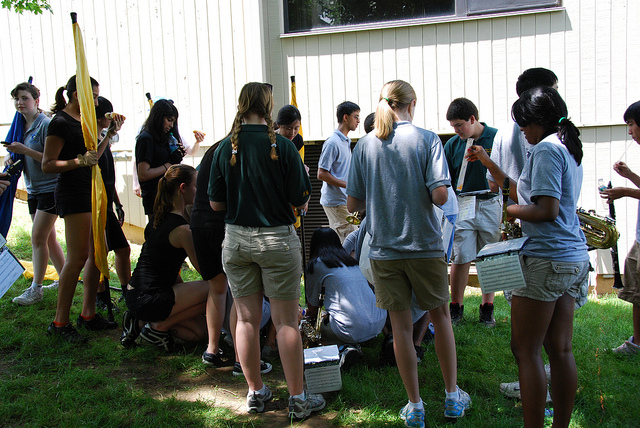<image>What kind of flag is in the background? There is no flag in the background. What kind of flag is in the background? I am not sure what kind of flag is in the background. It can be seen 'american', 'yellow' or 'color guard'. 